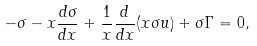Convert formula to latex. <formula><loc_0><loc_0><loc_500><loc_500>- \sigma - x \frac { d \sigma } { d x } + \frac { 1 } { x } \frac { d } { d x } ( x \sigma u ) + \sigma \Gamma = 0 ,</formula> 